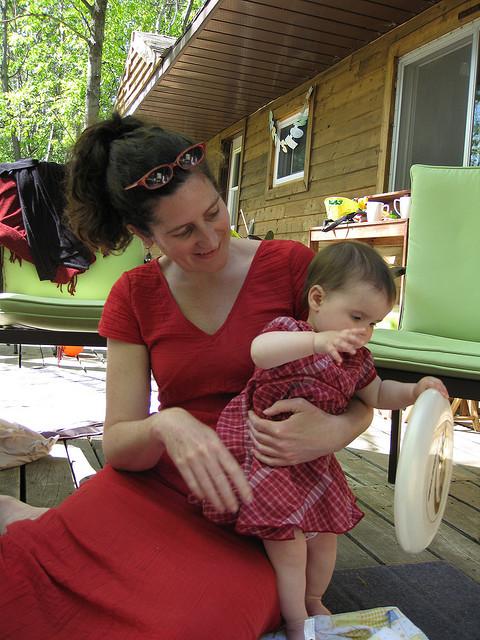What is the baby playing with?
Answer briefly. Frisbee. What color dresses are the mom and baby wearing?
Be succinct. Red. What color are the chairs?
Quick response, please. Green. 